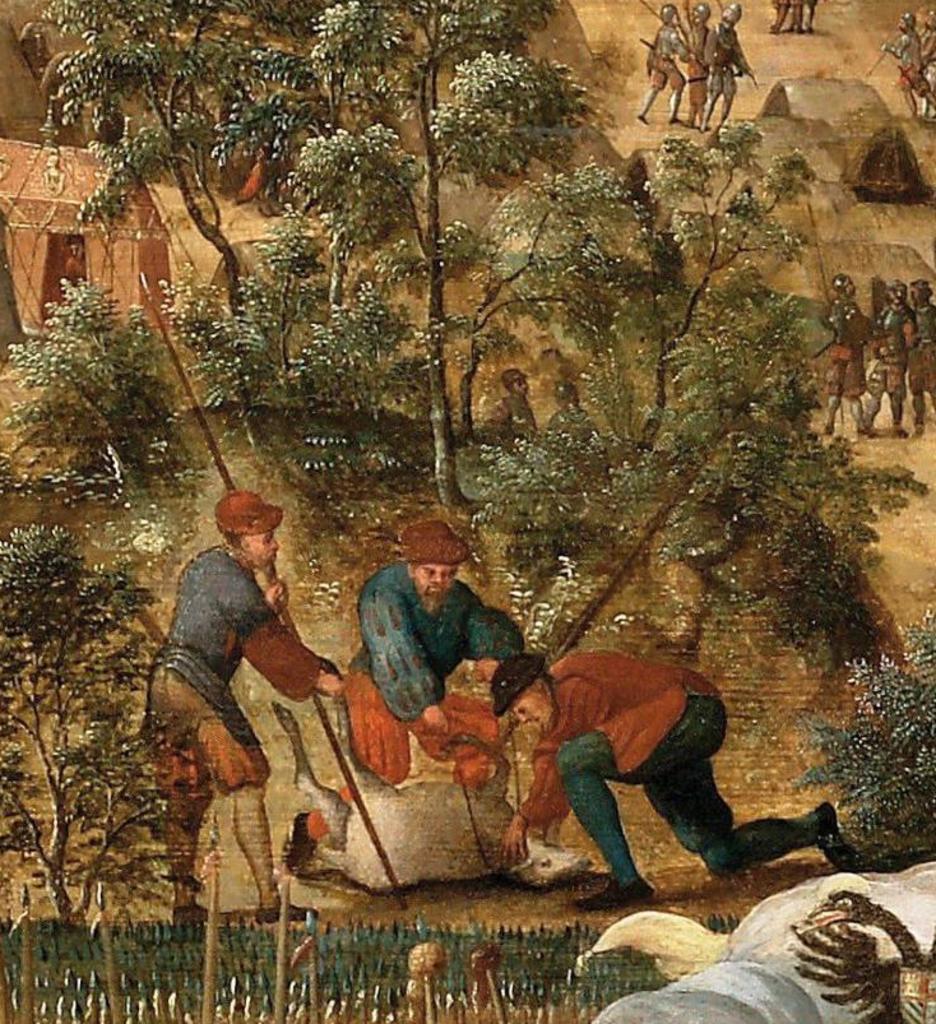Can you describe this image briefly? In this image, we can see a painting. Here there are few people. Here we can see an animal is laying on the ground. On the right side bottom corner, we can see few birds. At the bottom of the image, we can see fencing. Here we can see few trees, plants and houses. 